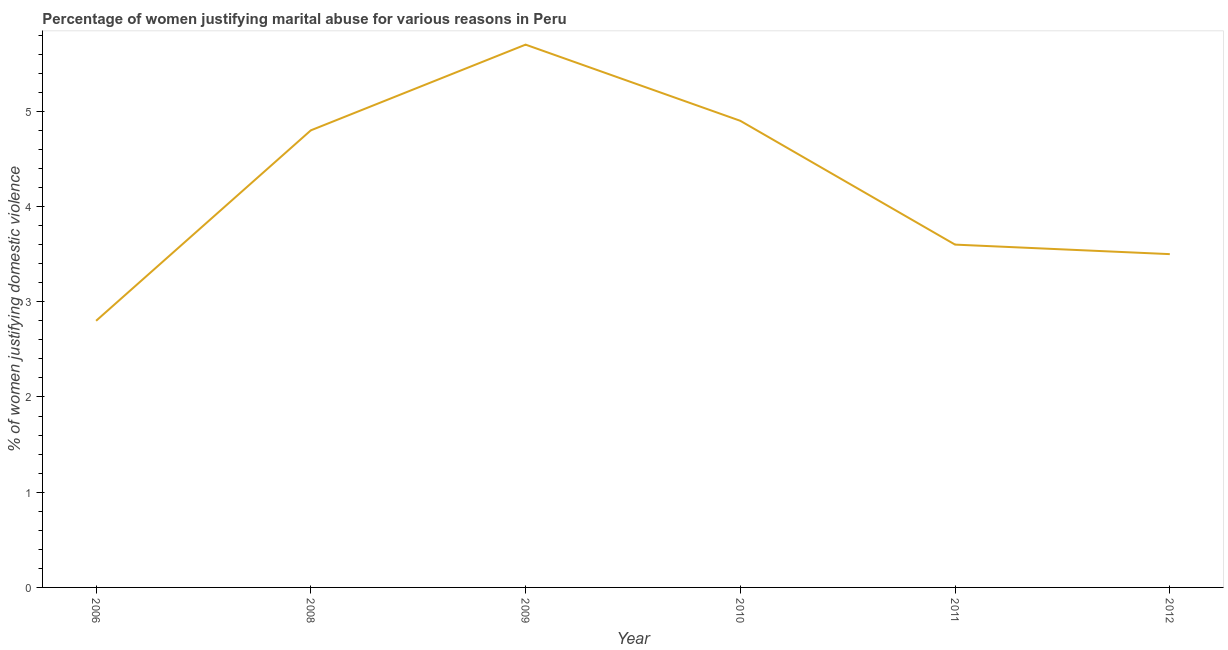Across all years, what is the minimum percentage of women justifying marital abuse?
Provide a succinct answer. 2.8. In which year was the percentage of women justifying marital abuse minimum?
Make the answer very short. 2006. What is the sum of the percentage of women justifying marital abuse?
Keep it short and to the point. 25.3. What is the difference between the percentage of women justifying marital abuse in 2011 and 2012?
Make the answer very short. 0.1. What is the average percentage of women justifying marital abuse per year?
Make the answer very short. 4.22. What is the median percentage of women justifying marital abuse?
Your answer should be very brief. 4.2. Do a majority of the years between 2009 and 2008 (inclusive) have percentage of women justifying marital abuse greater than 5.6 %?
Provide a succinct answer. No. What is the ratio of the percentage of women justifying marital abuse in 2006 to that in 2010?
Your answer should be very brief. 0.57. What is the difference between the highest and the second highest percentage of women justifying marital abuse?
Give a very brief answer. 0.8. What is the difference between the highest and the lowest percentage of women justifying marital abuse?
Your answer should be very brief. 2.9. How many lines are there?
Your answer should be very brief. 1. How many years are there in the graph?
Ensure brevity in your answer.  6. Are the values on the major ticks of Y-axis written in scientific E-notation?
Keep it short and to the point. No. What is the title of the graph?
Your response must be concise. Percentage of women justifying marital abuse for various reasons in Peru. What is the label or title of the X-axis?
Your answer should be very brief. Year. What is the label or title of the Y-axis?
Your answer should be very brief. % of women justifying domestic violence. What is the % of women justifying domestic violence in 2009?
Your response must be concise. 5.7. What is the % of women justifying domestic violence in 2010?
Keep it short and to the point. 4.9. What is the % of women justifying domestic violence in 2011?
Keep it short and to the point. 3.6. What is the difference between the % of women justifying domestic violence in 2006 and 2009?
Keep it short and to the point. -2.9. What is the difference between the % of women justifying domestic violence in 2006 and 2010?
Your answer should be compact. -2.1. What is the difference between the % of women justifying domestic violence in 2006 and 2011?
Provide a succinct answer. -0.8. What is the difference between the % of women justifying domestic violence in 2006 and 2012?
Your answer should be very brief. -0.7. What is the difference between the % of women justifying domestic violence in 2008 and 2009?
Your response must be concise. -0.9. What is the difference between the % of women justifying domestic violence in 2008 and 2010?
Keep it short and to the point. -0.1. What is the difference between the % of women justifying domestic violence in 2008 and 2011?
Your response must be concise. 1.2. What is the difference between the % of women justifying domestic violence in 2009 and 2010?
Offer a very short reply. 0.8. What is the difference between the % of women justifying domestic violence in 2010 and 2011?
Your response must be concise. 1.3. What is the difference between the % of women justifying domestic violence in 2010 and 2012?
Ensure brevity in your answer.  1.4. What is the difference between the % of women justifying domestic violence in 2011 and 2012?
Your response must be concise. 0.1. What is the ratio of the % of women justifying domestic violence in 2006 to that in 2008?
Your answer should be very brief. 0.58. What is the ratio of the % of women justifying domestic violence in 2006 to that in 2009?
Your answer should be very brief. 0.49. What is the ratio of the % of women justifying domestic violence in 2006 to that in 2010?
Your answer should be very brief. 0.57. What is the ratio of the % of women justifying domestic violence in 2006 to that in 2011?
Your response must be concise. 0.78. What is the ratio of the % of women justifying domestic violence in 2006 to that in 2012?
Your answer should be compact. 0.8. What is the ratio of the % of women justifying domestic violence in 2008 to that in 2009?
Provide a short and direct response. 0.84. What is the ratio of the % of women justifying domestic violence in 2008 to that in 2010?
Offer a very short reply. 0.98. What is the ratio of the % of women justifying domestic violence in 2008 to that in 2011?
Provide a succinct answer. 1.33. What is the ratio of the % of women justifying domestic violence in 2008 to that in 2012?
Ensure brevity in your answer.  1.37. What is the ratio of the % of women justifying domestic violence in 2009 to that in 2010?
Offer a very short reply. 1.16. What is the ratio of the % of women justifying domestic violence in 2009 to that in 2011?
Give a very brief answer. 1.58. What is the ratio of the % of women justifying domestic violence in 2009 to that in 2012?
Provide a short and direct response. 1.63. What is the ratio of the % of women justifying domestic violence in 2010 to that in 2011?
Your response must be concise. 1.36. What is the ratio of the % of women justifying domestic violence in 2010 to that in 2012?
Make the answer very short. 1.4. 